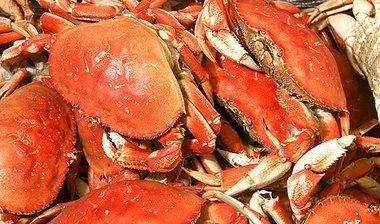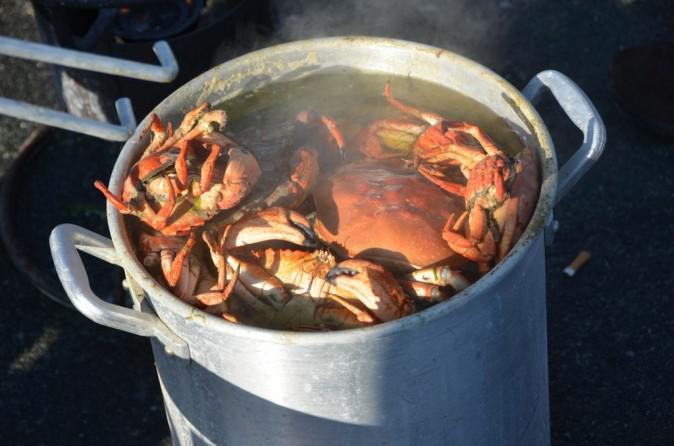The first image is the image on the left, the second image is the image on the right. Considering the images on both sides, is "The crabs in the left image are mostly brown in color; they are not tinted red." valid? Answer yes or no. No. The first image is the image on the left, the second image is the image on the right. Given the left and right images, does the statement "The right image shows crabs in a deep container, and the left image shows reddish-orange rightside-up crabs in a pile." hold true? Answer yes or no. Yes. 